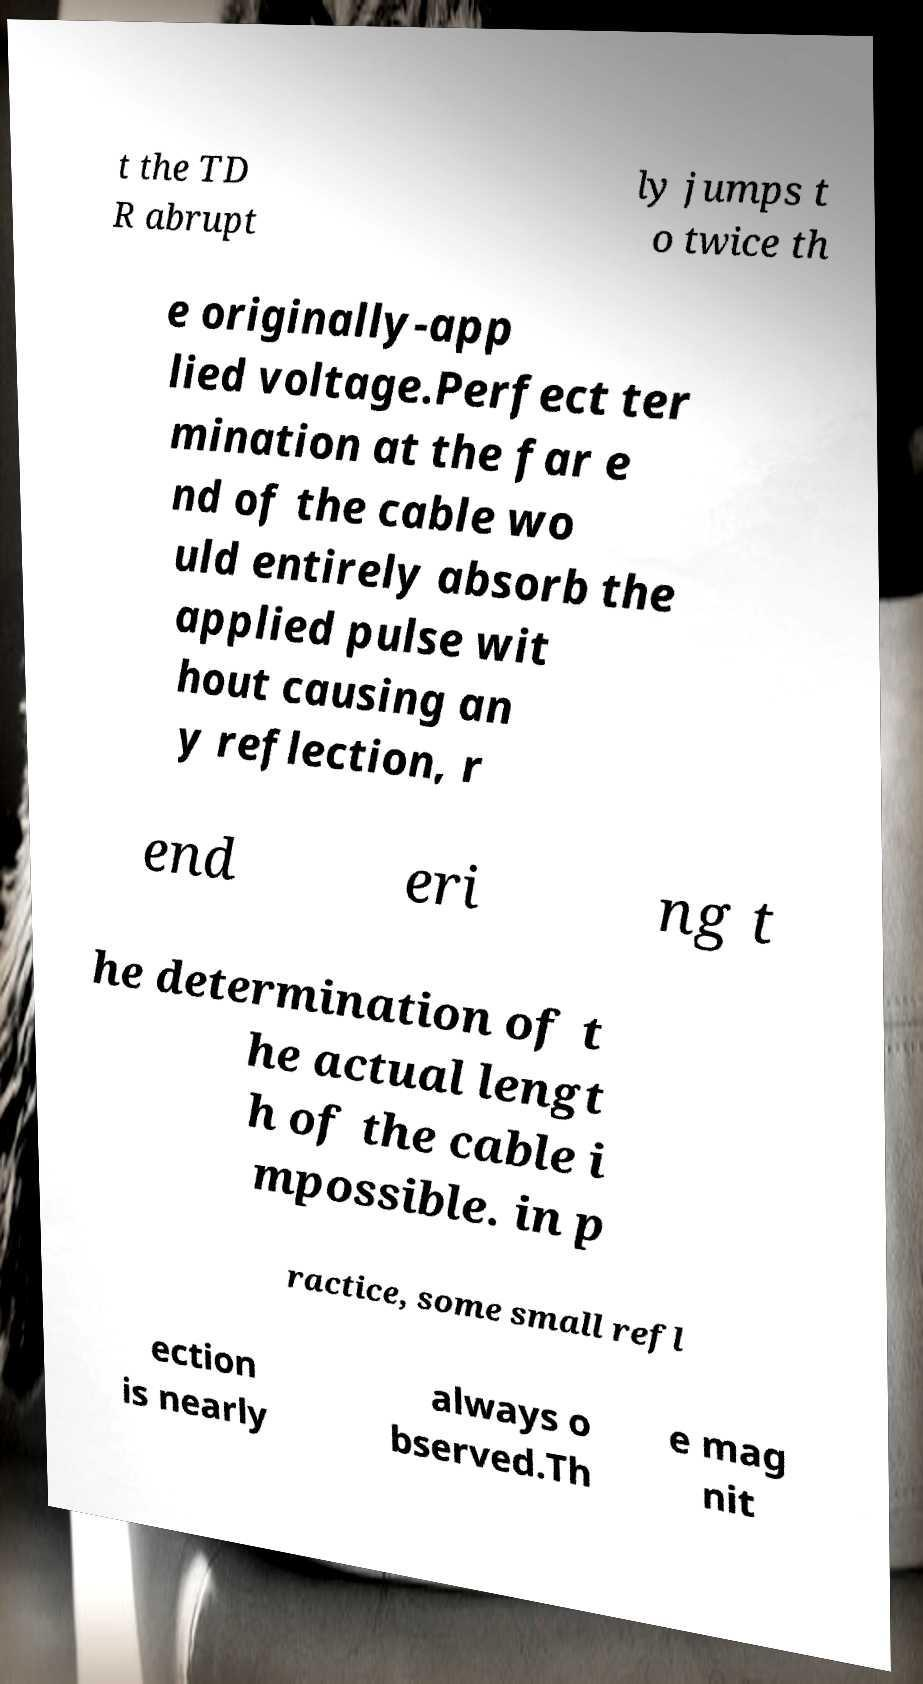For documentation purposes, I need the text within this image transcribed. Could you provide that? t the TD R abrupt ly jumps t o twice th e originally-app lied voltage.Perfect ter mination at the far e nd of the cable wo uld entirely absorb the applied pulse wit hout causing an y reflection, r end eri ng t he determination of t he actual lengt h of the cable i mpossible. in p ractice, some small refl ection is nearly always o bserved.Th e mag nit 